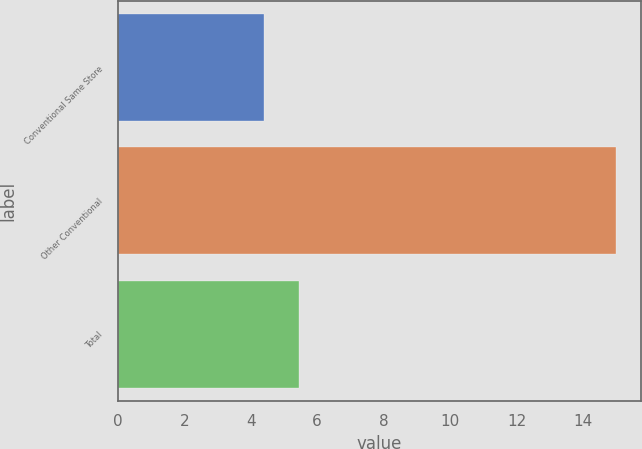Convert chart to OTSL. <chart><loc_0><loc_0><loc_500><loc_500><bar_chart><fcel>Conventional Same Store<fcel>Other Conventional<fcel>Total<nl><fcel>4.4<fcel>15<fcel>5.46<nl></chart> 